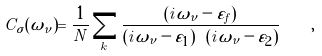<formula> <loc_0><loc_0><loc_500><loc_500>C _ { \sigma } ( \omega _ { \nu } ) = \frac { 1 } { N } \sum _ { k } \frac { ( i \omega _ { \nu } - \varepsilon _ { f } ) } { ( i \omega _ { \nu } - \varepsilon _ { 1 } ) \ ( i \omega _ { \nu } - \varepsilon _ { 2 } ) } \quad ,</formula> 